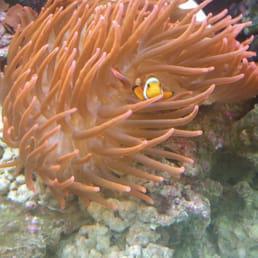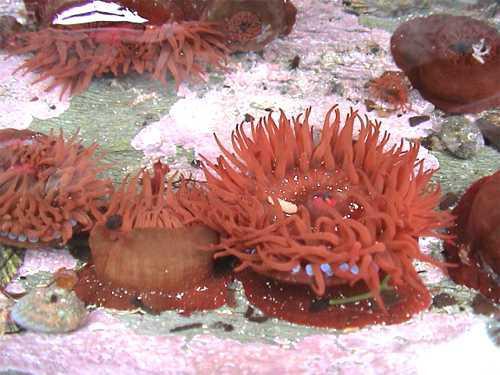The first image is the image on the left, the second image is the image on the right. Analyze the images presented: Is the assertion "All images feature anemone with tapering non-spike 'soft' tendrils, but one image features an anemone that has a deeper and more solid color than the other image." valid? Answer yes or no. Yes. The first image is the image on the left, the second image is the image on the right. For the images shown, is this caption "One of the images has more than three anemones visible." true? Answer yes or no. Yes. 